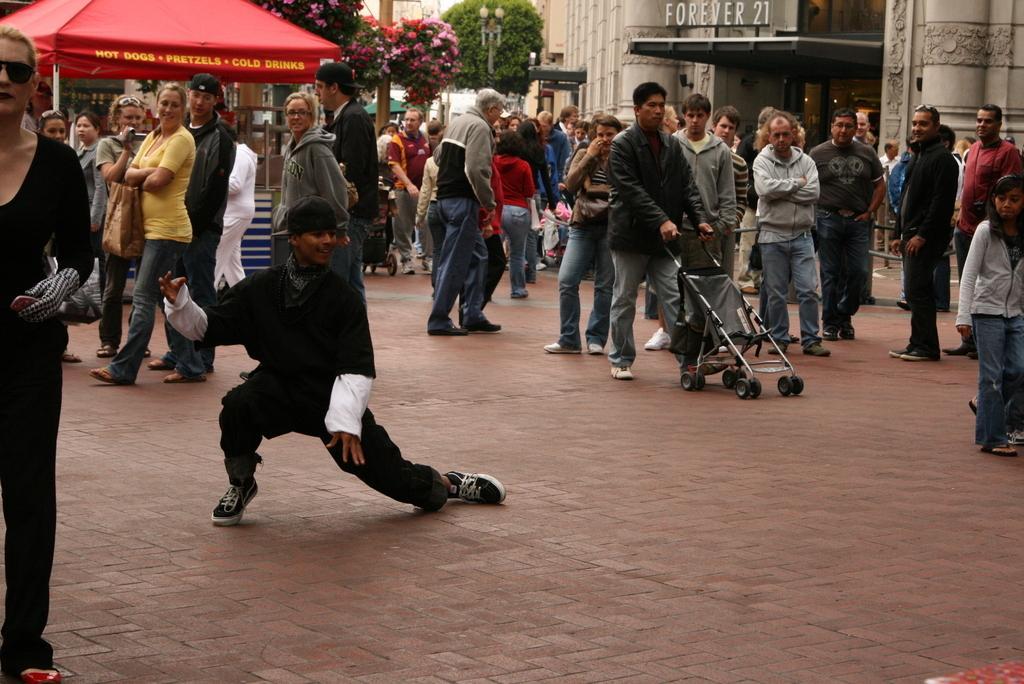How would you summarize this image in a sentence or two? In this image we can see so many men and women are standing on the road. Background of the image we can see tree, building and shelter. 